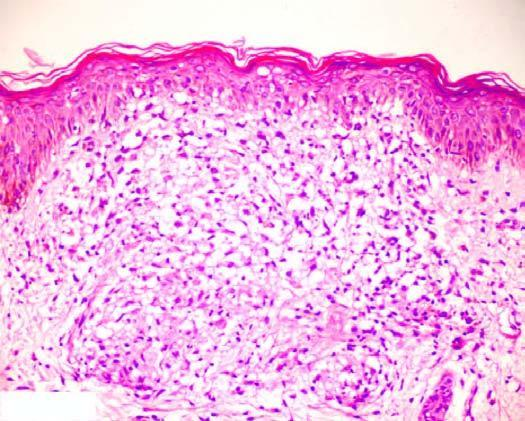s congo red composed of epithelioid cells with sparse langhans ' giant cells and lymphocytes?
Answer the question using a single word or phrase. No 